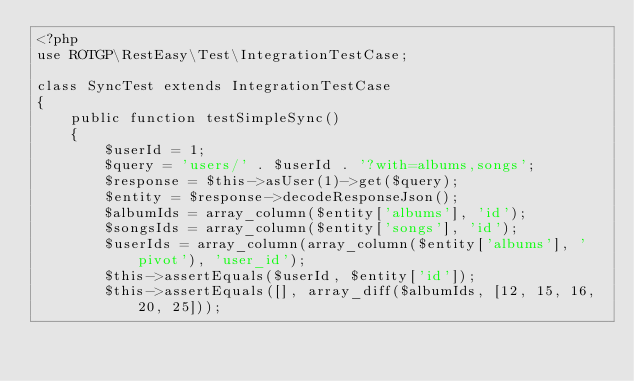Convert code to text. <code><loc_0><loc_0><loc_500><loc_500><_PHP_><?php
use ROTGP\RestEasy\Test\IntegrationTestCase;

class SyncTest extends IntegrationTestCase
{
    public function testSimpleSync()
    {
        $userId = 1;
        $query = 'users/' . $userId . '?with=albums,songs';
        $response = $this->asUser(1)->get($query);
        $entity = $response->decodeResponseJson();
        $albumIds = array_column($entity['albums'], 'id');
        $songsIds = array_column($entity['songs'], 'id');
        $userIds = array_column(array_column($entity['albums'], 'pivot'), 'user_id');
        $this->assertEquals($userId, $entity['id']);
        $this->assertEquals([], array_diff($albumIds, [12, 15, 16, 20, 25]));</code> 